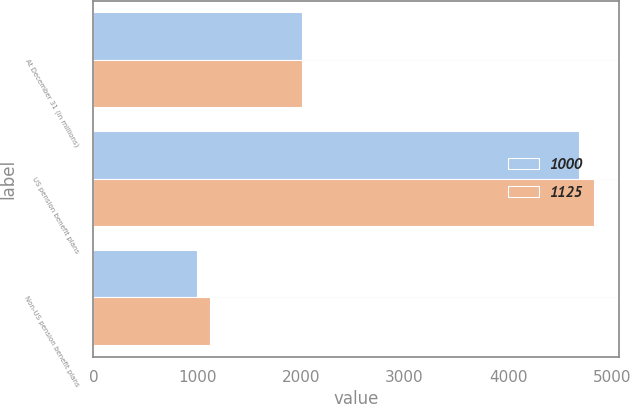Convert chart. <chart><loc_0><loc_0><loc_500><loc_500><stacked_bar_chart><ecel><fcel>At December 31 (in millions)<fcel>US pension benefit plans<fcel>Non-US pension benefit plans<nl><fcel>1000<fcel>2013<fcel>4683<fcel>1000<nl><fcel>1125<fcel>2012<fcel>4827<fcel>1125<nl></chart> 